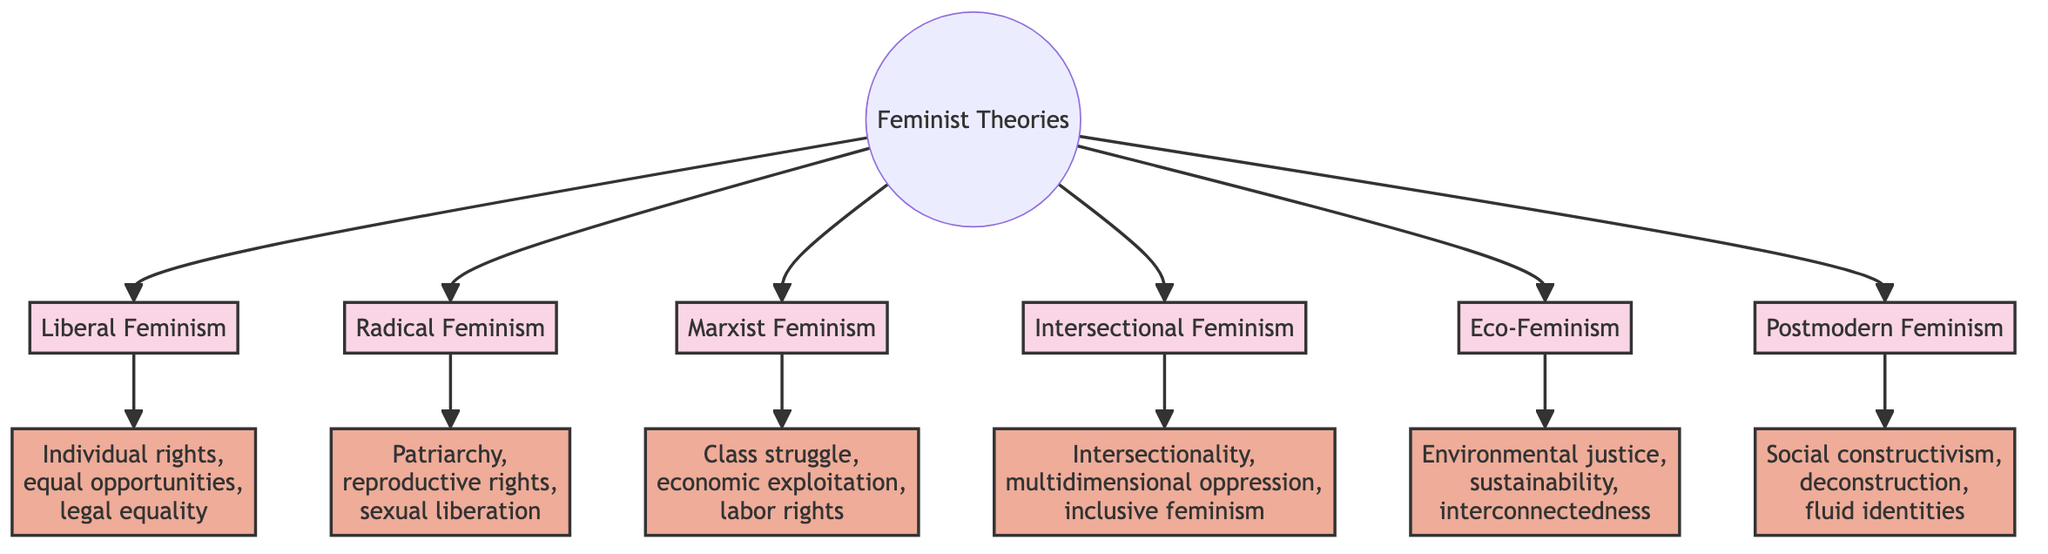What are the two main branches of feminist theory represented in the diagram? The diagram identifies six branches of feminist theory, but two of them can be highlighted: Liberal Feminism and Radical Feminism. This can be determined by examining the primary nodes that connect to the central node "Feminist Theories."
Answer: Liberal Feminism, Radical Feminism How many key principles are listed under Radical Feminism? By observing the node "KeyPrinciplesRadical," we see that it includes three principles: patriarchy, reproductive rights, and sexual liberation. Therefore, the count of principles can be confirmed directly from the node's content.
Answer: 3 Which feminist framework emphasizes environmental justice? To find this, we look for the framework associated with "Environmental justice," which is identified as a key principle of Eco-Feminism in the diagram. The connection indicates that Eco-Feminism is the framework focusing on this principle.
Answer: Eco-Feminism What is the relationship between Intersectional Feminism and the principle of multidimensional oppression? The diagram shows that Intersectional Feminism is linked to KeyPrinciplesIntersectional, which includes "multidimensional oppression" as one of its key principles. This indicates a direct relationship where Intersectional Feminism embodies this principle.
Answer: Direct How many feminist frameworks are present in the diagram? By counting the branches that flow from the main node "Feminist Theories," we find a total of six frameworks: Liberal Feminism, Radical Feminism, Marxist Feminism, Intersectional Feminism, Eco-Feminism, and Postmodern Feminism. Thus, we confirm the total count.
Answer: 6 What is the core principle associated with Postmodern Feminism? The node connected to Postmodern Feminism is KeyPrinciplesPostmodern, which lists the key principles as social constructivism, deconstruction, and fluid identities. Thus, any of these can be identified as a core principle of Postmodern Feminism, and we can present any of them as a concise answer.
Answer: Social constructivism 